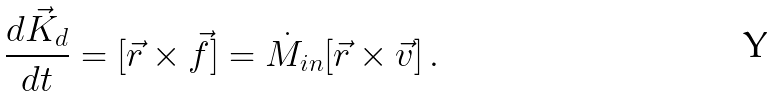Convert formula to latex. <formula><loc_0><loc_0><loc_500><loc_500>\frac { d \vec { K } _ { d } } { d t } = [ \vec { r } \times \vec { f } ] = \dot { M } _ { i n } [ \vec { r } \times \vec { v } ] \, .</formula> 